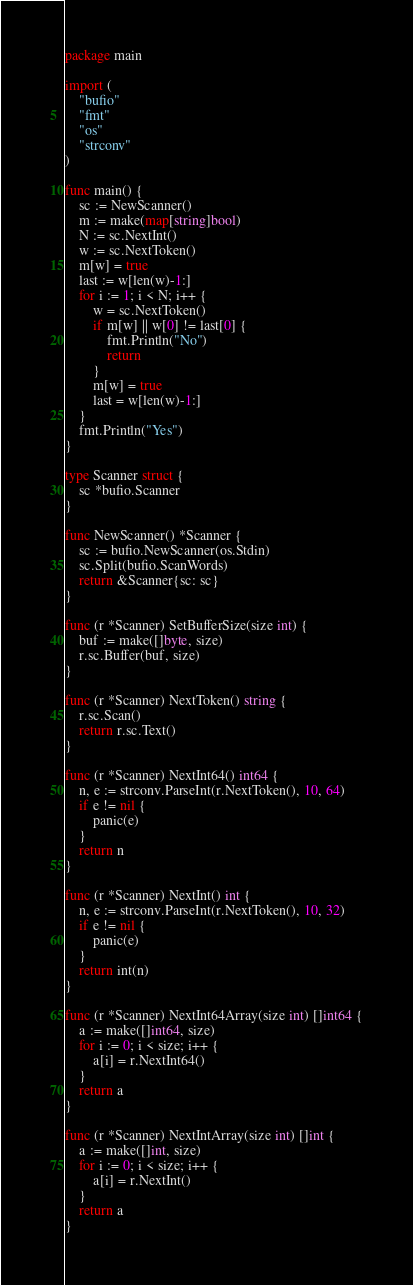Convert code to text. <code><loc_0><loc_0><loc_500><loc_500><_Go_>package main

import (
	"bufio"
	"fmt"
	"os"
	"strconv"
)

func main() {
	sc := NewScanner()
	m := make(map[string]bool)
    N := sc.NextInt()
    w := sc.NextToken()
    m[w] = true
    last := w[len(w)-1:]
    for i := 1; i < N; i++ {
        w = sc.NextToken()
        if m[w] || w[0] != last[0] {
            fmt.Println("No")
            return
        }
        m[w] = true
        last = w[len(w)-1:]
    }
    fmt.Println("Yes")
}

type Scanner struct {
	sc *bufio.Scanner
}

func NewScanner() *Scanner {
	sc := bufio.NewScanner(os.Stdin)
	sc.Split(bufio.ScanWords)
	return &Scanner{sc: sc}
}

func (r *Scanner) SetBufferSize(size int) {
	buf := make([]byte, size)
	r.sc.Buffer(buf, size)
}

func (r *Scanner) NextToken() string {
	r.sc.Scan()
	return r.sc.Text()
}

func (r *Scanner) NextInt64() int64 {
	n, e := strconv.ParseInt(r.NextToken(), 10, 64)
	if e != nil {
		panic(e)
	}
	return n
}

func (r *Scanner) NextInt() int {
	n, e := strconv.ParseInt(r.NextToken(), 10, 32)
	if e != nil {
		panic(e)
	}
	return int(n)
}

func (r *Scanner) NextInt64Array(size int) []int64 {
	a := make([]int64, size)
	for i := 0; i < size; i++ {
		a[i] = r.NextInt64()
	}
	return a
}

func (r *Scanner) NextIntArray(size int) []int {
	a := make([]int, size)
	for i := 0; i < size; i++ {
		a[i] = r.NextInt()
	}
	return a
}
</code> 